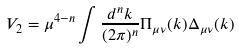<formula> <loc_0><loc_0><loc_500><loc_500>V _ { 2 } = \mu ^ { 4 - n } \int \frac { d ^ { n } k } { ( 2 \pi ) ^ { n } } \Pi _ { \mu \nu } ( k ) \Delta _ { \mu \nu } ( k )</formula> 